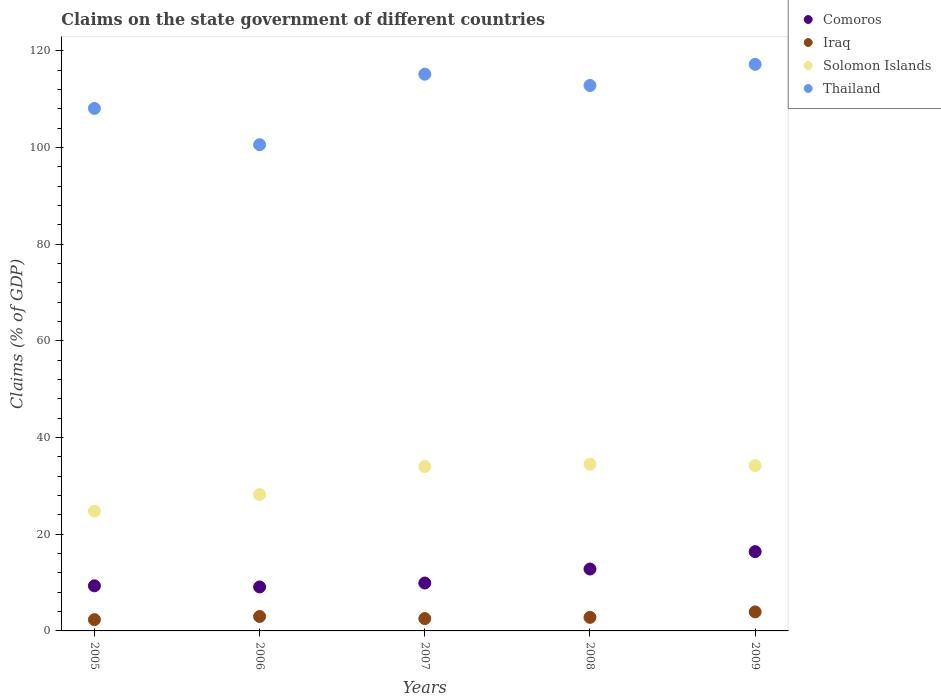Is the number of dotlines equal to the number of legend labels?
Your answer should be compact. Yes. What is the percentage of GDP claimed on the state government in Solomon Islands in 2005?
Offer a terse response. 24.79. Across all years, what is the maximum percentage of GDP claimed on the state government in Iraq?
Offer a terse response. 3.93. Across all years, what is the minimum percentage of GDP claimed on the state government in Solomon Islands?
Make the answer very short. 24.79. In which year was the percentage of GDP claimed on the state government in Solomon Islands maximum?
Make the answer very short. 2008. What is the total percentage of GDP claimed on the state government in Solomon Islands in the graph?
Provide a succinct answer. 155.69. What is the difference between the percentage of GDP claimed on the state government in Comoros in 2006 and that in 2009?
Give a very brief answer. -7.3. What is the difference between the percentage of GDP claimed on the state government in Comoros in 2005 and the percentage of GDP claimed on the state government in Solomon Islands in 2009?
Ensure brevity in your answer.  -24.87. What is the average percentage of GDP claimed on the state government in Thailand per year?
Provide a succinct answer. 110.78. In the year 2005, what is the difference between the percentage of GDP claimed on the state government in Thailand and percentage of GDP claimed on the state government in Iraq?
Ensure brevity in your answer.  105.76. What is the ratio of the percentage of GDP claimed on the state government in Comoros in 2005 to that in 2007?
Your answer should be compact. 0.94. Is the percentage of GDP claimed on the state government in Solomon Islands in 2006 less than that in 2008?
Your answer should be very brief. Yes. What is the difference between the highest and the second highest percentage of GDP claimed on the state government in Comoros?
Provide a succinct answer. 3.6. What is the difference between the highest and the lowest percentage of GDP claimed on the state government in Thailand?
Offer a very short reply. 16.62. Is it the case that in every year, the sum of the percentage of GDP claimed on the state government in Comoros and percentage of GDP claimed on the state government in Thailand  is greater than the sum of percentage of GDP claimed on the state government in Solomon Islands and percentage of GDP claimed on the state government in Iraq?
Keep it short and to the point. Yes. Is it the case that in every year, the sum of the percentage of GDP claimed on the state government in Thailand and percentage of GDP claimed on the state government in Comoros  is greater than the percentage of GDP claimed on the state government in Solomon Islands?
Give a very brief answer. Yes. How many dotlines are there?
Keep it short and to the point. 4. Are the values on the major ticks of Y-axis written in scientific E-notation?
Provide a short and direct response. No. Does the graph contain any zero values?
Provide a short and direct response. No. Does the graph contain grids?
Ensure brevity in your answer.  No. How many legend labels are there?
Keep it short and to the point. 4. How are the legend labels stacked?
Give a very brief answer. Vertical. What is the title of the graph?
Give a very brief answer. Claims on the state government of different countries. What is the label or title of the Y-axis?
Your answer should be very brief. Claims (% of GDP). What is the Claims (% of GDP) of Comoros in 2005?
Give a very brief answer. 9.33. What is the Claims (% of GDP) of Iraq in 2005?
Give a very brief answer. 2.33. What is the Claims (% of GDP) of Solomon Islands in 2005?
Provide a short and direct response. 24.79. What is the Claims (% of GDP) of Thailand in 2005?
Ensure brevity in your answer.  108.09. What is the Claims (% of GDP) in Comoros in 2006?
Keep it short and to the point. 9.1. What is the Claims (% of GDP) of Iraq in 2006?
Provide a succinct answer. 2.99. What is the Claims (% of GDP) of Solomon Islands in 2006?
Offer a very short reply. 28.21. What is the Claims (% of GDP) in Thailand in 2006?
Ensure brevity in your answer.  100.58. What is the Claims (% of GDP) of Comoros in 2007?
Your answer should be compact. 9.91. What is the Claims (% of GDP) in Iraq in 2007?
Make the answer very short. 2.55. What is the Claims (% of GDP) of Solomon Islands in 2007?
Keep it short and to the point. 34.01. What is the Claims (% of GDP) in Thailand in 2007?
Offer a terse response. 115.17. What is the Claims (% of GDP) in Comoros in 2008?
Provide a short and direct response. 12.81. What is the Claims (% of GDP) in Iraq in 2008?
Make the answer very short. 2.8. What is the Claims (% of GDP) in Solomon Islands in 2008?
Offer a very short reply. 34.48. What is the Claims (% of GDP) in Thailand in 2008?
Your answer should be very brief. 112.84. What is the Claims (% of GDP) of Comoros in 2009?
Ensure brevity in your answer.  16.4. What is the Claims (% of GDP) in Iraq in 2009?
Make the answer very short. 3.93. What is the Claims (% of GDP) of Solomon Islands in 2009?
Provide a succinct answer. 34.2. What is the Claims (% of GDP) in Thailand in 2009?
Your answer should be compact. 117.21. Across all years, what is the maximum Claims (% of GDP) of Comoros?
Offer a very short reply. 16.4. Across all years, what is the maximum Claims (% of GDP) in Iraq?
Provide a succinct answer. 3.93. Across all years, what is the maximum Claims (% of GDP) in Solomon Islands?
Offer a terse response. 34.48. Across all years, what is the maximum Claims (% of GDP) in Thailand?
Provide a short and direct response. 117.21. Across all years, what is the minimum Claims (% of GDP) in Comoros?
Keep it short and to the point. 9.1. Across all years, what is the minimum Claims (% of GDP) of Iraq?
Provide a short and direct response. 2.33. Across all years, what is the minimum Claims (% of GDP) of Solomon Islands?
Keep it short and to the point. 24.79. Across all years, what is the minimum Claims (% of GDP) of Thailand?
Your answer should be very brief. 100.58. What is the total Claims (% of GDP) of Comoros in the graph?
Provide a succinct answer. 57.55. What is the total Claims (% of GDP) in Iraq in the graph?
Your answer should be compact. 14.61. What is the total Claims (% of GDP) in Solomon Islands in the graph?
Ensure brevity in your answer.  155.69. What is the total Claims (% of GDP) of Thailand in the graph?
Your answer should be very brief. 553.89. What is the difference between the Claims (% of GDP) of Comoros in 2005 and that in 2006?
Your response must be concise. 0.23. What is the difference between the Claims (% of GDP) in Iraq in 2005 and that in 2006?
Keep it short and to the point. -0.66. What is the difference between the Claims (% of GDP) in Solomon Islands in 2005 and that in 2006?
Give a very brief answer. -3.42. What is the difference between the Claims (% of GDP) of Thailand in 2005 and that in 2006?
Your answer should be very brief. 7.51. What is the difference between the Claims (% of GDP) of Comoros in 2005 and that in 2007?
Give a very brief answer. -0.58. What is the difference between the Claims (% of GDP) of Iraq in 2005 and that in 2007?
Provide a succinct answer. -0.22. What is the difference between the Claims (% of GDP) of Solomon Islands in 2005 and that in 2007?
Offer a terse response. -9.23. What is the difference between the Claims (% of GDP) of Thailand in 2005 and that in 2007?
Offer a very short reply. -7.08. What is the difference between the Claims (% of GDP) of Comoros in 2005 and that in 2008?
Offer a very short reply. -3.48. What is the difference between the Claims (% of GDP) in Iraq in 2005 and that in 2008?
Provide a succinct answer. -0.47. What is the difference between the Claims (% of GDP) of Solomon Islands in 2005 and that in 2008?
Keep it short and to the point. -9.69. What is the difference between the Claims (% of GDP) of Thailand in 2005 and that in 2008?
Offer a very short reply. -4.74. What is the difference between the Claims (% of GDP) of Comoros in 2005 and that in 2009?
Give a very brief answer. -7.08. What is the difference between the Claims (% of GDP) in Iraq in 2005 and that in 2009?
Provide a succinct answer. -1.6. What is the difference between the Claims (% of GDP) of Solomon Islands in 2005 and that in 2009?
Offer a terse response. -9.41. What is the difference between the Claims (% of GDP) of Thailand in 2005 and that in 2009?
Give a very brief answer. -9.12. What is the difference between the Claims (% of GDP) of Comoros in 2006 and that in 2007?
Keep it short and to the point. -0.81. What is the difference between the Claims (% of GDP) in Iraq in 2006 and that in 2007?
Provide a succinct answer. 0.43. What is the difference between the Claims (% of GDP) in Solomon Islands in 2006 and that in 2007?
Give a very brief answer. -5.8. What is the difference between the Claims (% of GDP) in Thailand in 2006 and that in 2007?
Provide a short and direct response. -14.59. What is the difference between the Claims (% of GDP) of Comoros in 2006 and that in 2008?
Provide a succinct answer. -3.7. What is the difference between the Claims (% of GDP) in Iraq in 2006 and that in 2008?
Offer a terse response. 0.18. What is the difference between the Claims (% of GDP) in Solomon Islands in 2006 and that in 2008?
Keep it short and to the point. -6.27. What is the difference between the Claims (% of GDP) in Thailand in 2006 and that in 2008?
Provide a short and direct response. -12.25. What is the difference between the Claims (% of GDP) in Comoros in 2006 and that in 2009?
Give a very brief answer. -7.3. What is the difference between the Claims (% of GDP) in Iraq in 2006 and that in 2009?
Give a very brief answer. -0.94. What is the difference between the Claims (% of GDP) of Solomon Islands in 2006 and that in 2009?
Provide a short and direct response. -5.99. What is the difference between the Claims (% of GDP) in Thailand in 2006 and that in 2009?
Give a very brief answer. -16.62. What is the difference between the Claims (% of GDP) in Comoros in 2007 and that in 2008?
Offer a terse response. -2.9. What is the difference between the Claims (% of GDP) in Iraq in 2007 and that in 2008?
Make the answer very short. -0.25. What is the difference between the Claims (% of GDP) of Solomon Islands in 2007 and that in 2008?
Ensure brevity in your answer.  -0.46. What is the difference between the Claims (% of GDP) in Thailand in 2007 and that in 2008?
Provide a short and direct response. 2.34. What is the difference between the Claims (% of GDP) in Comoros in 2007 and that in 2009?
Offer a very short reply. -6.49. What is the difference between the Claims (% of GDP) of Iraq in 2007 and that in 2009?
Offer a very short reply. -1.38. What is the difference between the Claims (% of GDP) in Solomon Islands in 2007 and that in 2009?
Provide a succinct answer. -0.18. What is the difference between the Claims (% of GDP) of Thailand in 2007 and that in 2009?
Keep it short and to the point. -2.04. What is the difference between the Claims (% of GDP) in Comoros in 2008 and that in 2009?
Provide a succinct answer. -3.6. What is the difference between the Claims (% of GDP) of Iraq in 2008 and that in 2009?
Offer a terse response. -1.13. What is the difference between the Claims (% of GDP) in Solomon Islands in 2008 and that in 2009?
Provide a short and direct response. 0.28. What is the difference between the Claims (% of GDP) of Thailand in 2008 and that in 2009?
Offer a terse response. -4.37. What is the difference between the Claims (% of GDP) in Comoros in 2005 and the Claims (% of GDP) in Iraq in 2006?
Your response must be concise. 6.34. What is the difference between the Claims (% of GDP) of Comoros in 2005 and the Claims (% of GDP) of Solomon Islands in 2006?
Your response must be concise. -18.88. What is the difference between the Claims (% of GDP) of Comoros in 2005 and the Claims (% of GDP) of Thailand in 2006?
Provide a short and direct response. -91.25. What is the difference between the Claims (% of GDP) of Iraq in 2005 and the Claims (% of GDP) of Solomon Islands in 2006?
Make the answer very short. -25.88. What is the difference between the Claims (% of GDP) in Iraq in 2005 and the Claims (% of GDP) in Thailand in 2006?
Keep it short and to the point. -98.25. What is the difference between the Claims (% of GDP) of Solomon Islands in 2005 and the Claims (% of GDP) of Thailand in 2006?
Ensure brevity in your answer.  -75.8. What is the difference between the Claims (% of GDP) in Comoros in 2005 and the Claims (% of GDP) in Iraq in 2007?
Offer a very short reply. 6.77. What is the difference between the Claims (% of GDP) of Comoros in 2005 and the Claims (% of GDP) of Solomon Islands in 2007?
Your answer should be compact. -24.68. What is the difference between the Claims (% of GDP) of Comoros in 2005 and the Claims (% of GDP) of Thailand in 2007?
Provide a short and direct response. -105.84. What is the difference between the Claims (% of GDP) in Iraq in 2005 and the Claims (% of GDP) in Solomon Islands in 2007?
Your answer should be very brief. -31.68. What is the difference between the Claims (% of GDP) in Iraq in 2005 and the Claims (% of GDP) in Thailand in 2007?
Give a very brief answer. -112.84. What is the difference between the Claims (% of GDP) in Solomon Islands in 2005 and the Claims (% of GDP) in Thailand in 2007?
Your answer should be very brief. -90.38. What is the difference between the Claims (% of GDP) of Comoros in 2005 and the Claims (% of GDP) of Iraq in 2008?
Ensure brevity in your answer.  6.53. What is the difference between the Claims (% of GDP) of Comoros in 2005 and the Claims (% of GDP) of Solomon Islands in 2008?
Keep it short and to the point. -25.15. What is the difference between the Claims (% of GDP) in Comoros in 2005 and the Claims (% of GDP) in Thailand in 2008?
Your answer should be very brief. -103.51. What is the difference between the Claims (% of GDP) of Iraq in 2005 and the Claims (% of GDP) of Solomon Islands in 2008?
Make the answer very short. -32.15. What is the difference between the Claims (% of GDP) of Iraq in 2005 and the Claims (% of GDP) of Thailand in 2008?
Provide a short and direct response. -110.5. What is the difference between the Claims (% of GDP) in Solomon Islands in 2005 and the Claims (% of GDP) in Thailand in 2008?
Offer a terse response. -88.05. What is the difference between the Claims (% of GDP) of Comoros in 2005 and the Claims (% of GDP) of Iraq in 2009?
Offer a terse response. 5.4. What is the difference between the Claims (% of GDP) of Comoros in 2005 and the Claims (% of GDP) of Solomon Islands in 2009?
Provide a succinct answer. -24.87. What is the difference between the Claims (% of GDP) of Comoros in 2005 and the Claims (% of GDP) of Thailand in 2009?
Give a very brief answer. -107.88. What is the difference between the Claims (% of GDP) in Iraq in 2005 and the Claims (% of GDP) in Solomon Islands in 2009?
Make the answer very short. -31.87. What is the difference between the Claims (% of GDP) in Iraq in 2005 and the Claims (% of GDP) in Thailand in 2009?
Your answer should be compact. -114.88. What is the difference between the Claims (% of GDP) of Solomon Islands in 2005 and the Claims (% of GDP) of Thailand in 2009?
Your answer should be compact. -92.42. What is the difference between the Claims (% of GDP) in Comoros in 2006 and the Claims (% of GDP) in Iraq in 2007?
Your response must be concise. 6.55. What is the difference between the Claims (% of GDP) in Comoros in 2006 and the Claims (% of GDP) in Solomon Islands in 2007?
Your response must be concise. -24.91. What is the difference between the Claims (% of GDP) in Comoros in 2006 and the Claims (% of GDP) in Thailand in 2007?
Keep it short and to the point. -106.07. What is the difference between the Claims (% of GDP) in Iraq in 2006 and the Claims (% of GDP) in Solomon Islands in 2007?
Offer a very short reply. -31.03. What is the difference between the Claims (% of GDP) of Iraq in 2006 and the Claims (% of GDP) of Thailand in 2007?
Offer a terse response. -112.18. What is the difference between the Claims (% of GDP) of Solomon Islands in 2006 and the Claims (% of GDP) of Thailand in 2007?
Your response must be concise. -86.96. What is the difference between the Claims (% of GDP) of Comoros in 2006 and the Claims (% of GDP) of Iraq in 2008?
Provide a short and direct response. 6.3. What is the difference between the Claims (% of GDP) of Comoros in 2006 and the Claims (% of GDP) of Solomon Islands in 2008?
Provide a succinct answer. -25.38. What is the difference between the Claims (% of GDP) of Comoros in 2006 and the Claims (% of GDP) of Thailand in 2008?
Provide a succinct answer. -103.73. What is the difference between the Claims (% of GDP) of Iraq in 2006 and the Claims (% of GDP) of Solomon Islands in 2008?
Provide a short and direct response. -31.49. What is the difference between the Claims (% of GDP) in Iraq in 2006 and the Claims (% of GDP) in Thailand in 2008?
Provide a succinct answer. -109.85. What is the difference between the Claims (% of GDP) of Solomon Islands in 2006 and the Claims (% of GDP) of Thailand in 2008?
Offer a very short reply. -84.63. What is the difference between the Claims (% of GDP) of Comoros in 2006 and the Claims (% of GDP) of Iraq in 2009?
Ensure brevity in your answer.  5.17. What is the difference between the Claims (% of GDP) in Comoros in 2006 and the Claims (% of GDP) in Solomon Islands in 2009?
Provide a short and direct response. -25.1. What is the difference between the Claims (% of GDP) of Comoros in 2006 and the Claims (% of GDP) of Thailand in 2009?
Ensure brevity in your answer.  -108.11. What is the difference between the Claims (% of GDP) in Iraq in 2006 and the Claims (% of GDP) in Solomon Islands in 2009?
Your answer should be compact. -31.21. What is the difference between the Claims (% of GDP) in Iraq in 2006 and the Claims (% of GDP) in Thailand in 2009?
Your answer should be very brief. -114.22. What is the difference between the Claims (% of GDP) of Solomon Islands in 2006 and the Claims (% of GDP) of Thailand in 2009?
Your response must be concise. -89. What is the difference between the Claims (% of GDP) in Comoros in 2007 and the Claims (% of GDP) in Iraq in 2008?
Your answer should be very brief. 7.11. What is the difference between the Claims (% of GDP) in Comoros in 2007 and the Claims (% of GDP) in Solomon Islands in 2008?
Your answer should be very brief. -24.57. What is the difference between the Claims (% of GDP) of Comoros in 2007 and the Claims (% of GDP) of Thailand in 2008?
Provide a succinct answer. -102.93. What is the difference between the Claims (% of GDP) of Iraq in 2007 and the Claims (% of GDP) of Solomon Islands in 2008?
Ensure brevity in your answer.  -31.92. What is the difference between the Claims (% of GDP) of Iraq in 2007 and the Claims (% of GDP) of Thailand in 2008?
Make the answer very short. -110.28. What is the difference between the Claims (% of GDP) of Solomon Islands in 2007 and the Claims (% of GDP) of Thailand in 2008?
Offer a terse response. -78.82. What is the difference between the Claims (% of GDP) in Comoros in 2007 and the Claims (% of GDP) in Iraq in 2009?
Provide a succinct answer. 5.98. What is the difference between the Claims (% of GDP) in Comoros in 2007 and the Claims (% of GDP) in Solomon Islands in 2009?
Provide a short and direct response. -24.29. What is the difference between the Claims (% of GDP) in Comoros in 2007 and the Claims (% of GDP) in Thailand in 2009?
Offer a terse response. -107.3. What is the difference between the Claims (% of GDP) of Iraq in 2007 and the Claims (% of GDP) of Solomon Islands in 2009?
Offer a very short reply. -31.64. What is the difference between the Claims (% of GDP) of Iraq in 2007 and the Claims (% of GDP) of Thailand in 2009?
Provide a short and direct response. -114.65. What is the difference between the Claims (% of GDP) in Solomon Islands in 2007 and the Claims (% of GDP) in Thailand in 2009?
Provide a short and direct response. -83.19. What is the difference between the Claims (% of GDP) of Comoros in 2008 and the Claims (% of GDP) of Iraq in 2009?
Your answer should be compact. 8.87. What is the difference between the Claims (% of GDP) in Comoros in 2008 and the Claims (% of GDP) in Solomon Islands in 2009?
Provide a succinct answer. -21.39. What is the difference between the Claims (% of GDP) in Comoros in 2008 and the Claims (% of GDP) in Thailand in 2009?
Keep it short and to the point. -104.4. What is the difference between the Claims (% of GDP) of Iraq in 2008 and the Claims (% of GDP) of Solomon Islands in 2009?
Your answer should be very brief. -31.39. What is the difference between the Claims (% of GDP) in Iraq in 2008 and the Claims (% of GDP) in Thailand in 2009?
Make the answer very short. -114.4. What is the difference between the Claims (% of GDP) of Solomon Islands in 2008 and the Claims (% of GDP) of Thailand in 2009?
Give a very brief answer. -82.73. What is the average Claims (% of GDP) in Comoros per year?
Your answer should be compact. 11.51. What is the average Claims (% of GDP) of Iraq per year?
Your answer should be very brief. 2.92. What is the average Claims (% of GDP) of Solomon Islands per year?
Offer a terse response. 31.14. What is the average Claims (% of GDP) of Thailand per year?
Offer a terse response. 110.78. In the year 2005, what is the difference between the Claims (% of GDP) of Comoros and Claims (% of GDP) of Iraq?
Ensure brevity in your answer.  7. In the year 2005, what is the difference between the Claims (% of GDP) of Comoros and Claims (% of GDP) of Solomon Islands?
Offer a very short reply. -15.46. In the year 2005, what is the difference between the Claims (% of GDP) of Comoros and Claims (% of GDP) of Thailand?
Ensure brevity in your answer.  -98.76. In the year 2005, what is the difference between the Claims (% of GDP) of Iraq and Claims (% of GDP) of Solomon Islands?
Provide a short and direct response. -22.46. In the year 2005, what is the difference between the Claims (% of GDP) in Iraq and Claims (% of GDP) in Thailand?
Offer a terse response. -105.76. In the year 2005, what is the difference between the Claims (% of GDP) of Solomon Islands and Claims (% of GDP) of Thailand?
Make the answer very short. -83.31. In the year 2006, what is the difference between the Claims (% of GDP) of Comoros and Claims (% of GDP) of Iraq?
Offer a very short reply. 6.11. In the year 2006, what is the difference between the Claims (% of GDP) in Comoros and Claims (% of GDP) in Solomon Islands?
Offer a very short reply. -19.11. In the year 2006, what is the difference between the Claims (% of GDP) in Comoros and Claims (% of GDP) in Thailand?
Offer a very short reply. -91.48. In the year 2006, what is the difference between the Claims (% of GDP) of Iraq and Claims (% of GDP) of Solomon Islands?
Your response must be concise. -25.22. In the year 2006, what is the difference between the Claims (% of GDP) of Iraq and Claims (% of GDP) of Thailand?
Ensure brevity in your answer.  -97.6. In the year 2006, what is the difference between the Claims (% of GDP) in Solomon Islands and Claims (% of GDP) in Thailand?
Make the answer very short. -72.37. In the year 2007, what is the difference between the Claims (% of GDP) in Comoros and Claims (% of GDP) in Iraq?
Provide a short and direct response. 7.36. In the year 2007, what is the difference between the Claims (% of GDP) of Comoros and Claims (% of GDP) of Solomon Islands?
Your answer should be compact. -24.1. In the year 2007, what is the difference between the Claims (% of GDP) of Comoros and Claims (% of GDP) of Thailand?
Offer a terse response. -105.26. In the year 2007, what is the difference between the Claims (% of GDP) in Iraq and Claims (% of GDP) in Solomon Islands?
Offer a terse response. -31.46. In the year 2007, what is the difference between the Claims (% of GDP) in Iraq and Claims (% of GDP) in Thailand?
Your answer should be very brief. -112.62. In the year 2007, what is the difference between the Claims (% of GDP) of Solomon Islands and Claims (% of GDP) of Thailand?
Your response must be concise. -81.16. In the year 2008, what is the difference between the Claims (% of GDP) in Comoros and Claims (% of GDP) in Iraq?
Offer a terse response. 10. In the year 2008, what is the difference between the Claims (% of GDP) of Comoros and Claims (% of GDP) of Solomon Islands?
Provide a short and direct response. -21.67. In the year 2008, what is the difference between the Claims (% of GDP) in Comoros and Claims (% of GDP) in Thailand?
Provide a short and direct response. -100.03. In the year 2008, what is the difference between the Claims (% of GDP) in Iraq and Claims (% of GDP) in Solomon Islands?
Your response must be concise. -31.67. In the year 2008, what is the difference between the Claims (% of GDP) in Iraq and Claims (% of GDP) in Thailand?
Your answer should be compact. -110.03. In the year 2008, what is the difference between the Claims (% of GDP) of Solomon Islands and Claims (% of GDP) of Thailand?
Your response must be concise. -78.36. In the year 2009, what is the difference between the Claims (% of GDP) in Comoros and Claims (% of GDP) in Iraq?
Ensure brevity in your answer.  12.47. In the year 2009, what is the difference between the Claims (% of GDP) in Comoros and Claims (% of GDP) in Solomon Islands?
Ensure brevity in your answer.  -17.79. In the year 2009, what is the difference between the Claims (% of GDP) in Comoros and Claims (% of GDP) in Thailand?
Ensure brevity in your answer.  -100.8. In the year 2009, what is the difference between the Claims (% of GDP) in Iraq and Claims (% of GDP) in Solomon Islands?
Offer a terse response. -30.27. In the year 2009, what is the difference between the Claims (% of GDP) in Iraq and Claims (% of GDP) in Thailand?
Give a very brief answer. -113.28. In the year 2009, what is the difference between the Claims (% of GDP) in Solomon Islands and Claims (% of GDP) in Thailand?
Give a very brief answer. -83.01. What is the ratio of the Claims (% of GDP) in Comoros in 2005 to that in 2006?
Make the answer very short. 1.02. What is the ratio of the Claims (% of GDP) in Iraq in 2005 to that in 2006?
Provide a succinct answer. 0.78. What is the ratio of the Claims (% of GDP) in Solomon Islands in 2005 to that in 2006?
Offer a very short reply. 0.88. What is the ratio of the Claims (% of GDP) in Thailand in 2005 to that in 2006?
Provide a short and direct response. 1.07. What is the ratio of the Claims (% of GDP) of Comoros in 2005 to that in 2007?
Provide a succinct answer. 0.94. What is the ratio of the Claims (% of GDP) in Iraq in 2005 to that in 2007?
Your answer should be very brief. 0.91. What is the ratio of the Claims (% of GDP) of Solomon Islands in 2005 to that in 2007?
Provide a short and direct response. 0.73. What is the ratio of the Claims (% of GDP) of Thailand in 2005 to that in 2007?
Your answer should be compact. 0.94. What is the ratio of the Claims (% of GDP) of Comoros in 2005 to that in 2008?
Provide a short and direct response. 0.73. What is the ratio of the Claims (% of GDP) in Iraq in 2005 to that in 2008?
Your answer should be very brief. 0.83. What is the ratio of the Claims (% of GDP) in Solomon Islands in 2005 to that in 2008?
Give a very brief answer. 0.72. What is the ratio of the Claims (% of GDP) in Thailand in 2005 to that in 2008?
Provide a short and direct response. 0.96. What is the ratio of the Claims (% of GDP) of Comoros in 2005 to that in 2009?
Keep it short and to the point. 0.57. What is the ratio of the Claims (% of GDP) in Iraq in 2005 to that in 2009?
Keep it short and to the point. 0.59. What is the ratio of the Claims (% of GDP) of Solomon Islands in 2005 to that in 2009?
Your response must be concise. 0.72. What is the ratio of the Claims (% of GDP) of Thailand in 2005 to that in 2009?
Give a very brief answer. 0.92. What is the ratio of the Claims (% of GDP) in Comoros in 2006 to that in 2007?
Offer a terse response. 0.92. What is the ratio of the Claims (% of GDP) in Iraq in 2006 to that in 2007?
Give a very brief answer. 1.17. What is the ratio of the Claims (% of GDP) of Solomon Islands in 2006 to that in 2007?
Offer a very short reply. 0.83. What is the ratio of the Claims (% of GDP) of Thailand in 2006 to that in 2007?
Offer a very short reply. 0.87. What is the ratio of the Claims (% of GDP) of Comoros in 2006 to that in 2008?
Keep it short and to the point. 0.71. What is the ratio of the Claims (% of GDP) of Iraq in 2006 to that in 2008?
Keep it short and to the point. 1.07. What is the ratio of the Claims (% of GDP) in Solomon Islands in 2006 to that in 2008?
Make the answer very short. 0.82. What is the ratio of the Claims (% of GDP) in Thailand in 2006 to that in 2008?
Your answer should be compact. 0.89. What is the ratio of the Claims (% of GDP) of Comoros in 2006 to that in 2009?
Offer a terse response. 0.55. What is the ratio of the Claims (% of GDP) in Iraq in 2006 to that in 2009?
Ensure brevity in your answer.  0.76. What is the ratio of the Claims (% of GDP) in Solomon Islands in 2006 to that in 2009?
Your answer should be compact. 0.82. What is the ratio of the Claims (% of GDP) in Thailand in 2006 to that in 2009?
Keep it short and to the point. 0.86. What is the ratio of the Claims (% of GDP) in Comoros in 2007 to that in 2008?
Ensure brevity in your answer.  0.77. What is the ratio of the Claims (% of GDP) of Iraq in 2007 to that in 2008?
Provide a succinct answer. 0.91. What is the ratio of the Claims (% of GDP) in Solomon Islands in 2007 to that in 2008?
Offer a terse response. 0.99. What is the ratio of the Claims (% of GDP) of Thailand in 2007 to that in 2008?
Provide a succinct answer. 1.02. What is the ratio of the Claims (% of GDP) in Comoros in 2007 to that in 2009?
Keep it short and to the point. 0.6. What is the ratio of the Claims (% of GDP) in Iraq in 2007 to that in 2009?
Offer a terse response. 0.65. What is the ratio of the Claims (% of GDP) in Thailand in 2007 to that in 2009?
Ensure brevity in your answer.  0.98. What is the ratio of the Claims (% of GDP) in Comoros in 2008 to that in 2009?
Your response must be concise. 0.78. What is the ratio of the Claims (% of GDP) of Iraq in 2008 to that in 2009?
Provide a short and direct response. 0.71. What is the ratio of the Claims (% of GDP) in Solomon Islands in 2008 to that in 2009?
Ensure brevity in your answer.  1.01. What is the ratio of the Claims (% of GDP) in Thailand in 2008 to that in 2009?
Your answer should be compact. 0.96. What is the difference between the highest and the second highest Claims (% of GDP) in Comoros?
Offer a terse response. 3.6. What is the difference between the highest and the second highest Claims (% of GDP) of Iraq?
Ensure brevity in your answer.  0.94. What is the difference between the highest and the second highest Claims (% of GDP) of Solomon Islands?
Your response must be concise. 0.28. What is the difference between the highest and the second highest Claims (% of GDP) in Thailand?
Your response must be concise. 2.04. What is the difference between the highest and the lowest Claims (% of GDP) in Comoros?
Provide a short and direct response. 7.3. What is the difference between the highest and the lowest Claims (% of GDP) in Iraq?
Make the answer very short. 1.6. What is the difference between the highest and the lowest Claims (% of GDP) of Solomon Islands?
Provide a succinct answer. 9.69. What is the difference between the highest and the lowest Claims (% of GDP) of Thailand?
Your answer should be very brief. 16.62. 